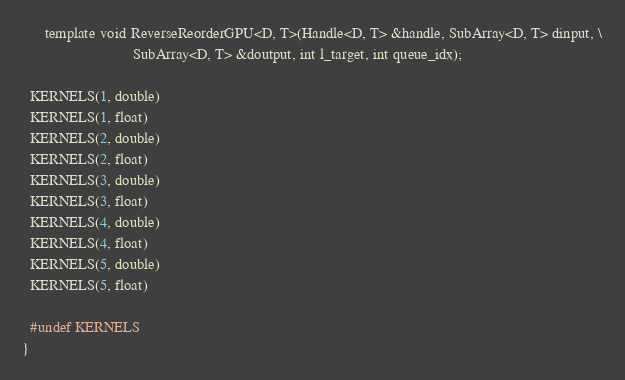Convert code to text. <code><loc_0><loc_0><loc_500><loc_500><_Cuda_>      template void ReverseReorderGPU<D, T>(Handle<D, T> &handle, SubArray<D, T> dinput, \
                             SubArray<D, T> &doutput, int l_target, int queue_idx);

  KERNELS(1, double)
  KERNELS(1, float)
  KERNELS(2, double)
  KERNELS(2, float)
  KERNELS(3, double)
  KERNELS(3, float)
  KERNELS(4, double)
  KERNELS(4, float)
  KERNELS(5, double)
  KERNELS(5, float)

  #undef KERNELS
}


</code> 